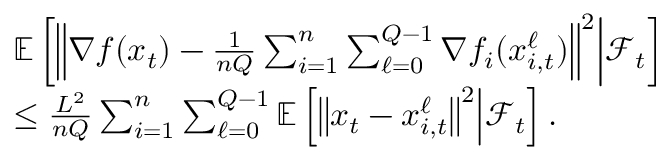<formula> <loc_0><loc_0><loc_500><loc_500>\begin{array} { r l } & { \mathbb { E } \left [ \left \| \nabla f ( x _ { t } ) - \frac { 1 } { n Q } \sum _ { i = 1 } ^ { n } \sum _ { \ell = 0 } ^ { Q - 1 } \nabla f _ { i } ( x _ { i , t } ^ { \ell } ) \right \| ^ { 2 } | d l e | \mathcal { F } _ { t } \right ] } \\ & { \leq \frac { L ^ { 2 } } { n Q } \sum _ { i = 1 } ^ { n } \sum _ { \ell = 0 } ^ { Q - 1 } \mathbb { E } \left [ \left \| x _ { t } - x _ { i , t } ^ { \ell } \right \| ^ { 2 } | d l e | \mathcal { F } _ { t } \right ] . } \end{array}</formula> 